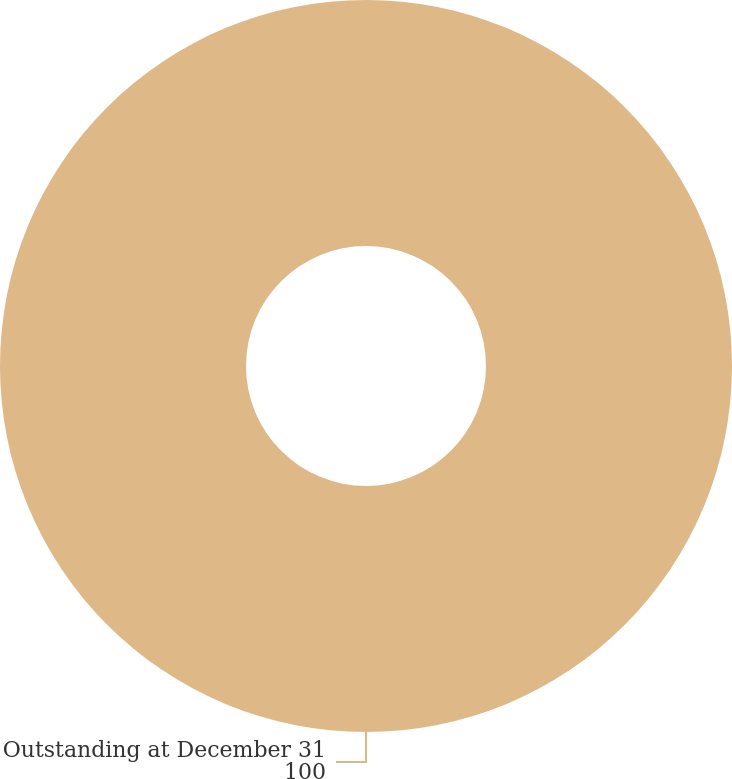<chart> <loc_0><loc_0><loc_500><loc_500><pie_chart><fcel>Outstanding at December 31<nl><fcel>100.0%<nl></chart> 